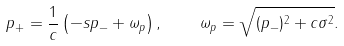Convert formula to latex. <formula><loc_0><loc_0><loc_500><loc_500>p _ { + } = { \frac { 1 } { c } } \left ( - s p _ { - } + \omega _ { p } \right ) , \quad \omega _ { p } = \sqrt { ( p _ { - } ) ^ { 2 } + c \sigma ^ { 2 } } .</formula> 